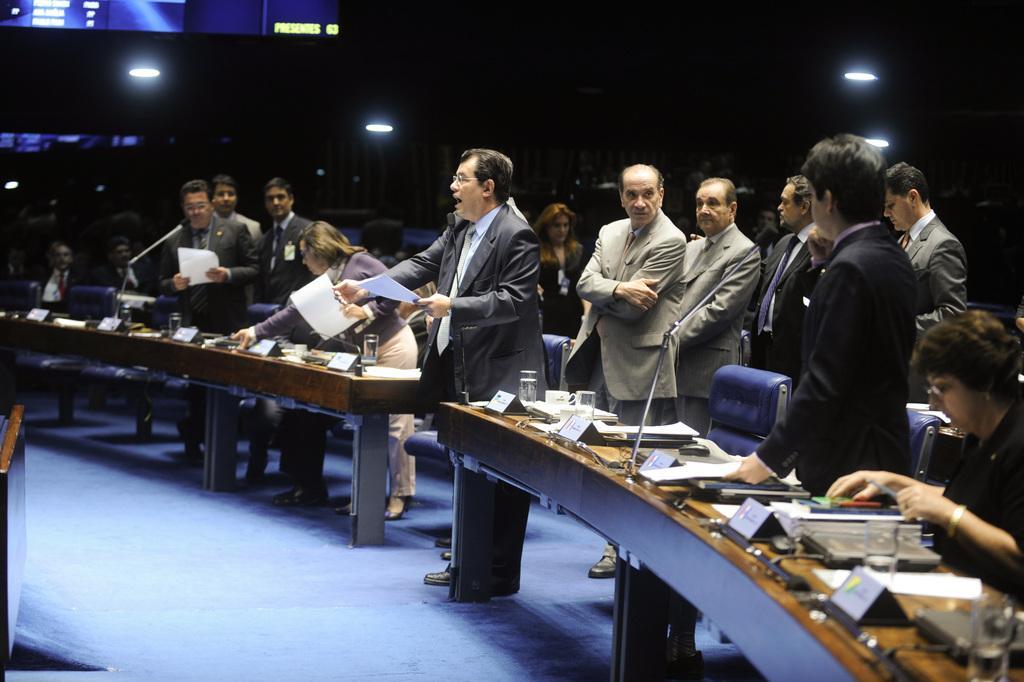In one or two sentences, can you explain what this image depicts? In the image there are many men in standing in suits in front of table with mics,papers,glasses on it, this is clicked in a conference room. 